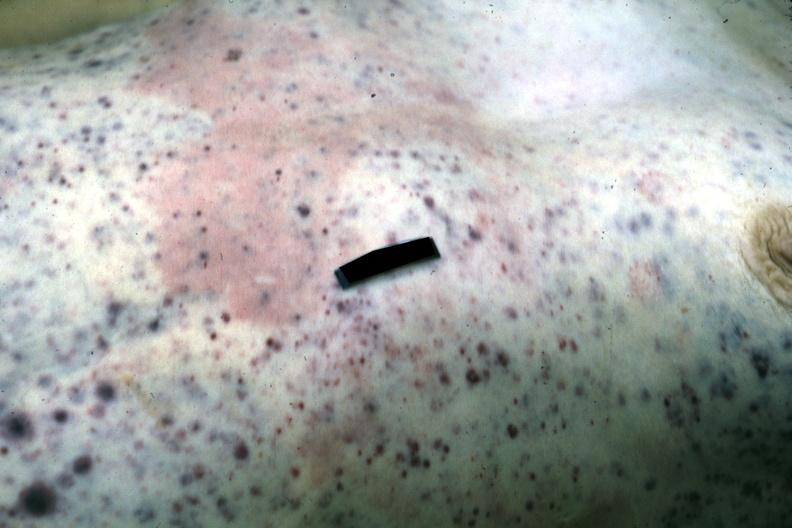does this image show but not good color petechiae and purpura case of stcell leukemia?
Answer the question using a single word or phrase. Yes 